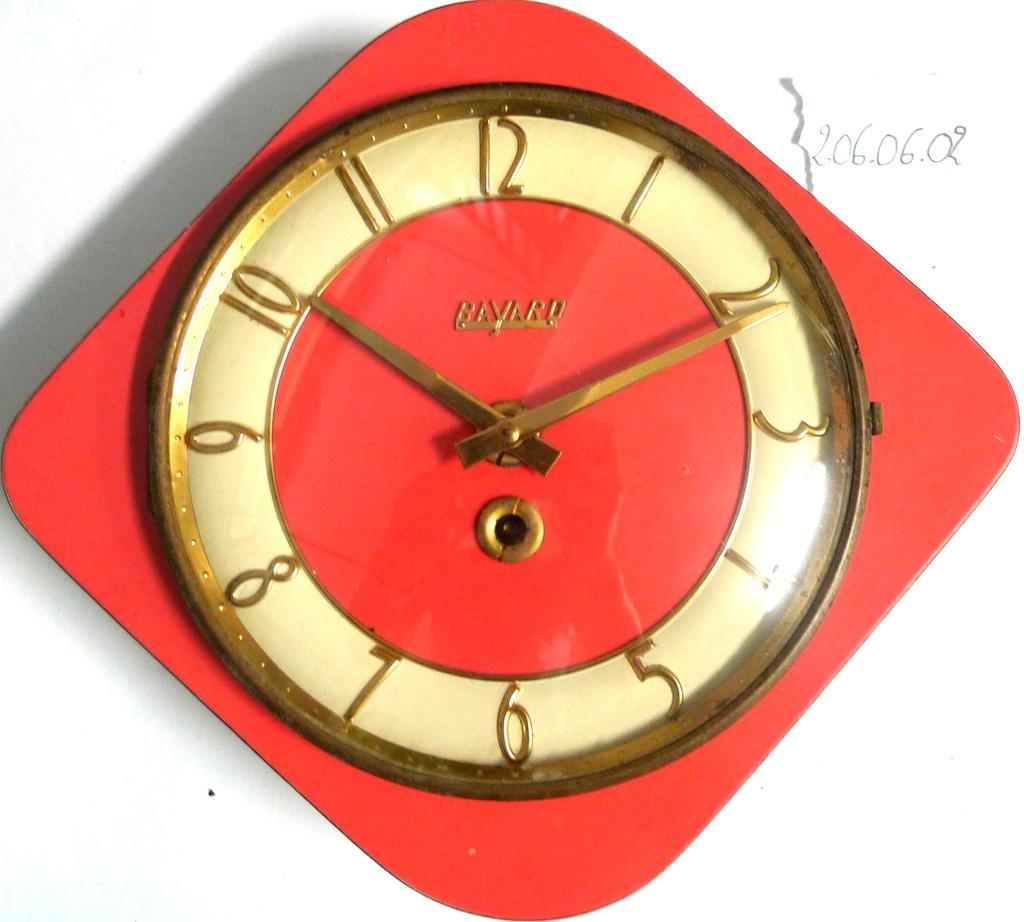What is the watch brand?
Your answer should be very brief. Bavard. What time is the clock?
Your answer should be compact. 10:11. 